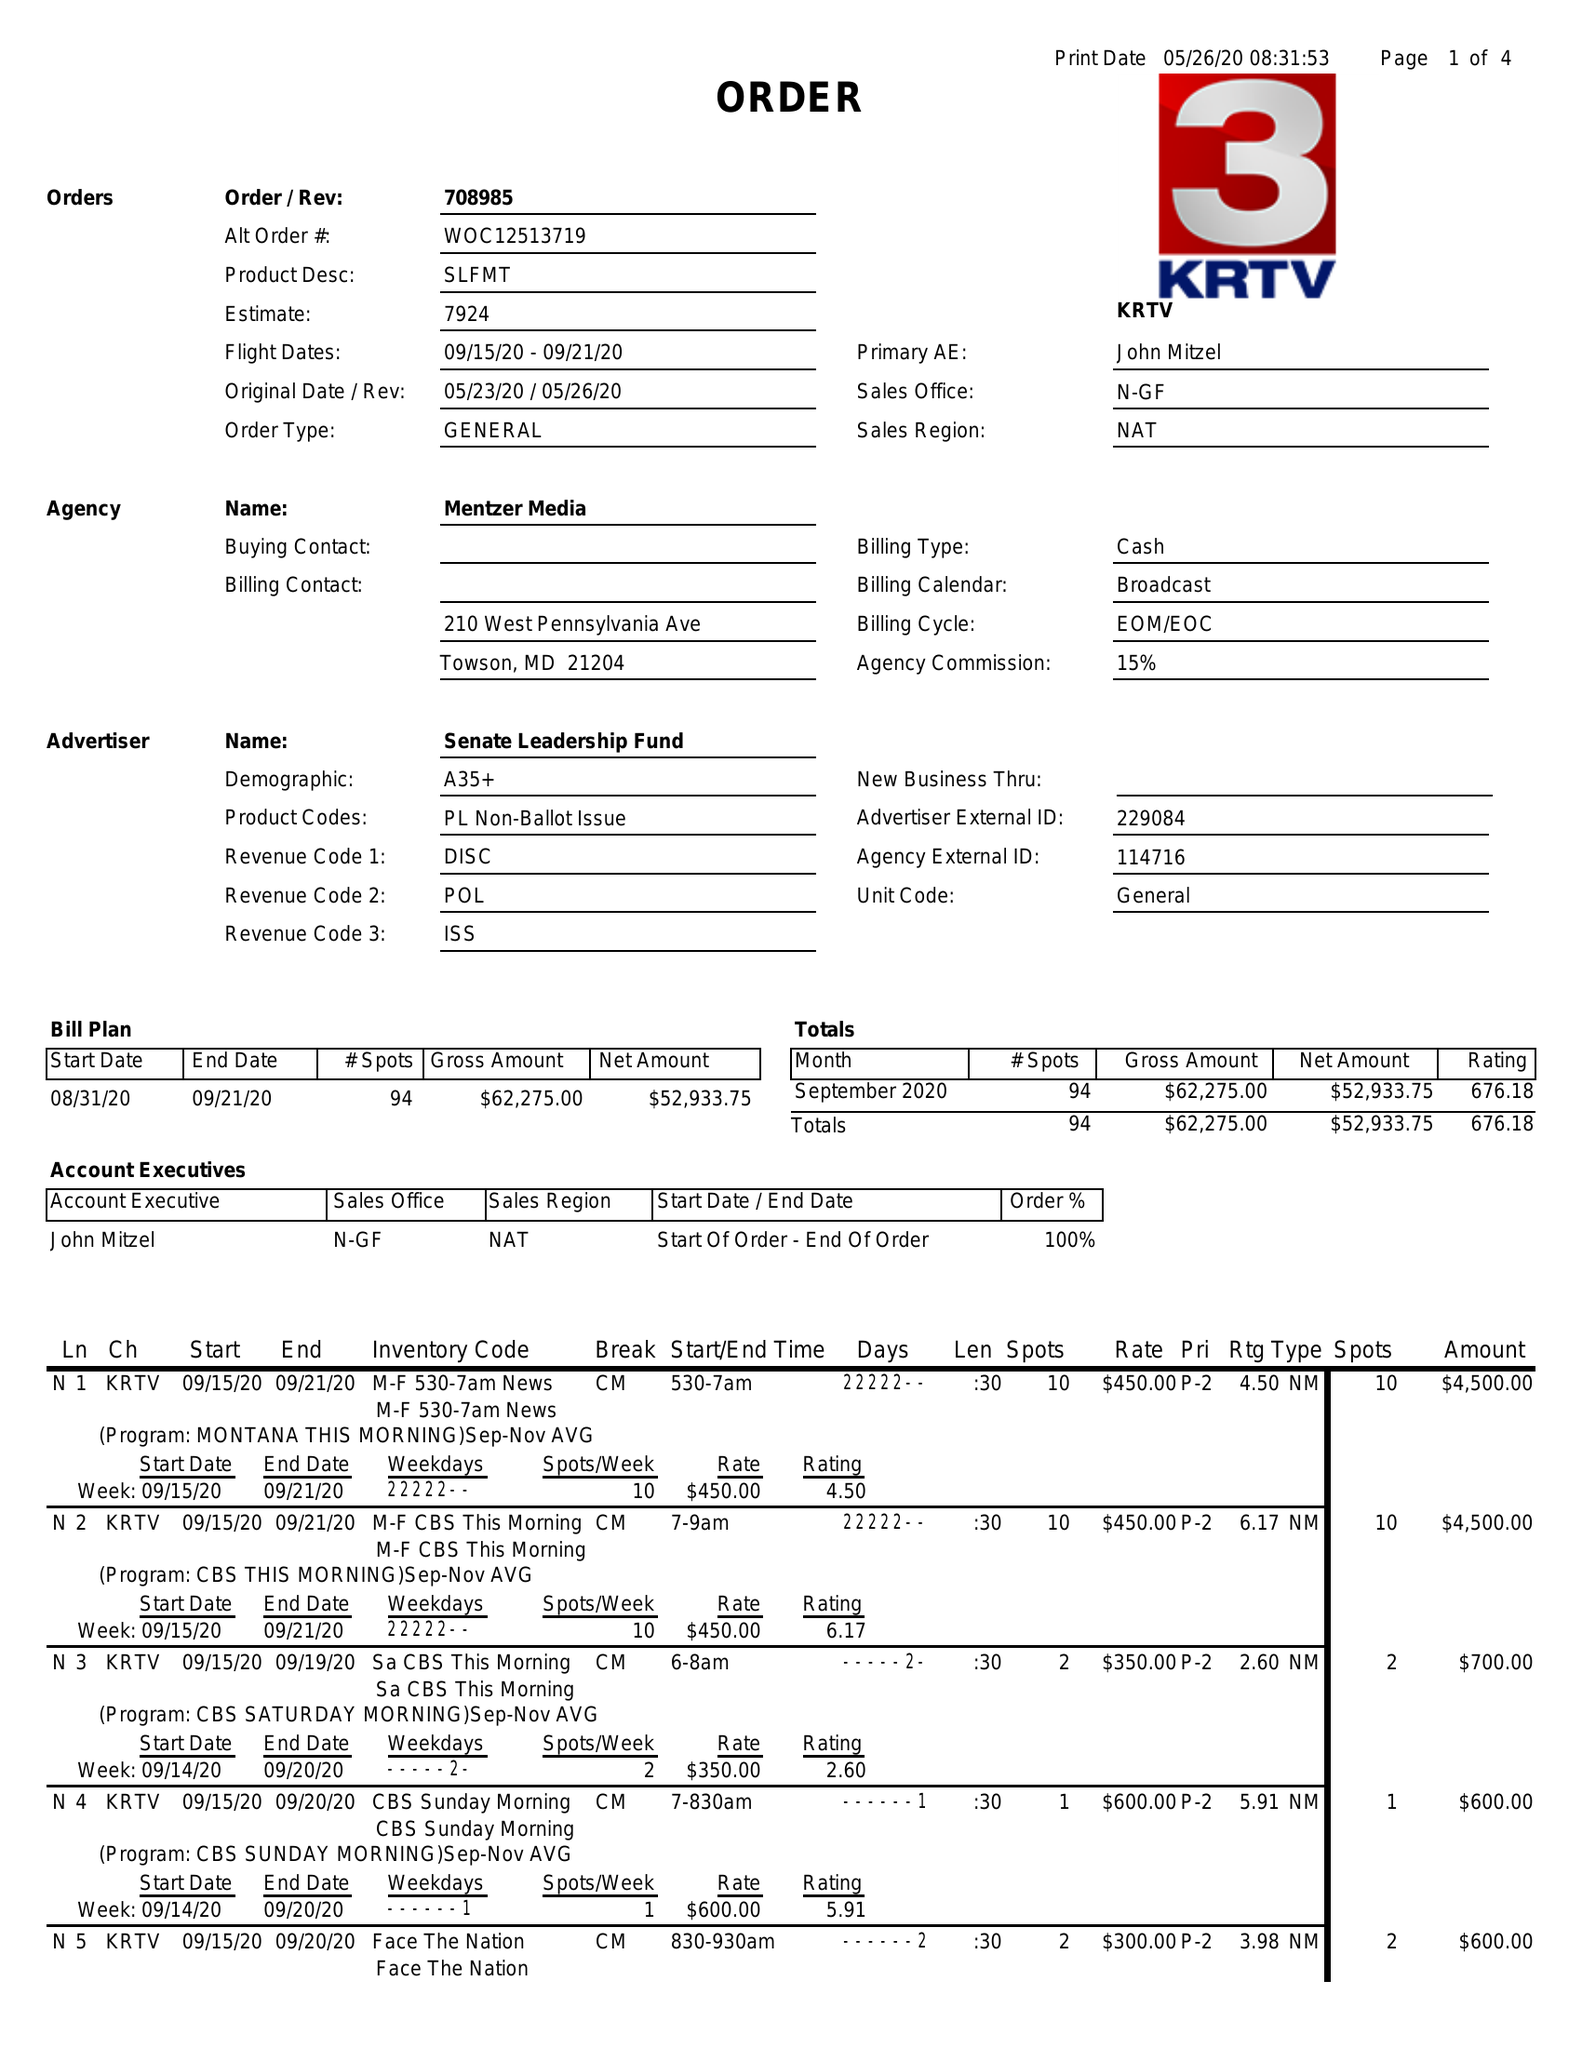What is the value for the flight_from?
Answer the question using a single word or phrase. 09/15/20 